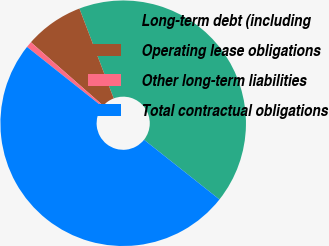<chart> <loc_0><loc_0><loc_500><loc_500><pie_chart><fcel>Long-term debt (including<fcel>Operating lease obligations<fcel>Other long-term liabilities<fcel>Total contractual obligations<nl><fcel>41.46%<fcel>7.73%<fcel>0.79%<fcel>50.02%<nl></chart> 